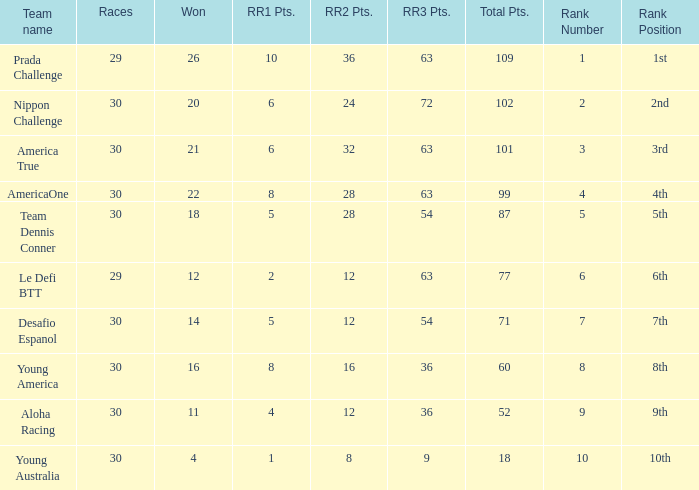Name the races for the prada challenge 29.0. 